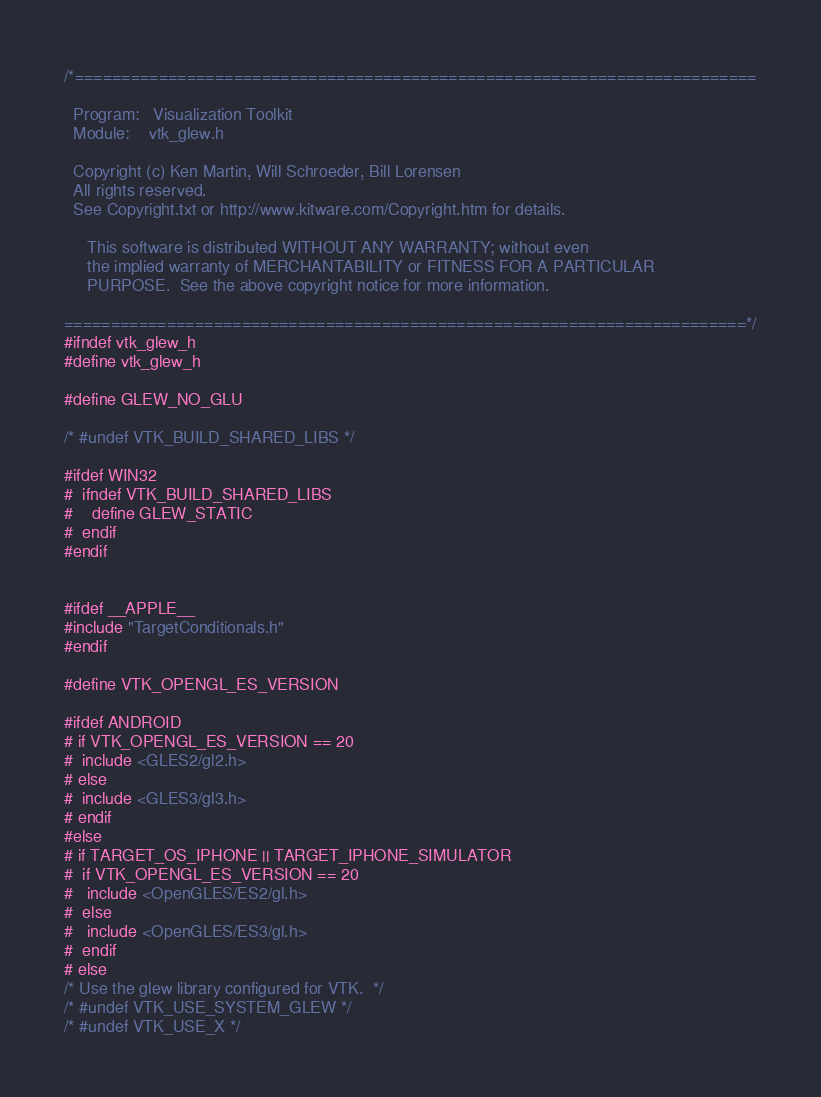Convert code to text. <code><loc_0><loc_0><loc_500><loc_500><_C_>/*=========================================================================

  Program:   Visualization Toolkit
  Module:    vtk_glew.h

  Copyright (c) Ken Martin, Will Schroeder, Bill Lorensen
  All rights reserved.
  See Copyright.txt or http://www.kitware.com/Copyright.htm for details.

     This software is distributed WITHOUT ANY WARRANTY; without even
     the implied warranty of MERCHANTABILITY or FITNESS FOR A PARTICULAR
     PURPOSE.  See the above copyright notice for more information.

=========================================================================*/
#ifndef vtk_glew_h
#define vtk_glew_h

#define GLEW_NO_GLU

/* #undef VTK_BUILD_SHARED_LIBS */

#ifdef WIN32
#  ifndef VTK_BUILD_SHARED_LIBS
#    define GLEW_STATIC
#  endif
#endif


#ifdef __APPLE__
#include "TargetConditionals.h"
#endif

#define VTK_OPENGL_ES_VERSION 

#ifdef ANDROID
# if VTK_OPENGL_ES_VERSION == 20
#  include <GLES2/gl2.h>
# else
#  include <GLES3/gl3.h>
# endif
#else
# if TARGET_OS_IPHONE || TARGET_IPHONE_SIMULATOR
#  if VTK_OPENGL_ES_VERSION == 20
#   include <OpenGLES/ES2/gl.h>
#  else
#   include <OpenGLES/ES3/gl.h>
#  endif
# else
/* Use the glew library configured for VTK.  */
/* #undef VTK_USE_SYSTEM_GLEW */
/* #undef VTK_USE_X */</code> 